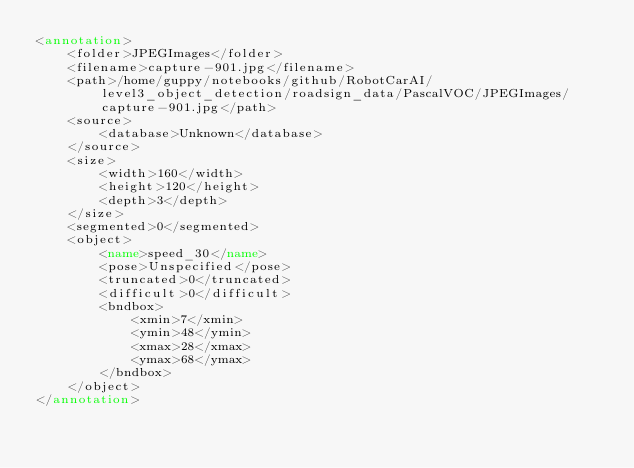Convert code to text. <code><loc_0><loc_0><loc_500><loc_500><_XML_><annotation>
	<folder>JPEGImages</folder>
	<filename>capture-901.jpg</filename>
	<path>/home/guppy/notebooks/github/RobotCarAI/level3_object_detection/roadsign_data/PascalVOC/JPEGImages/capture-901.jpg</path>
	<source>
		<database>Unknown</database>
	</source>
	<size>
		<width>160</width>
		<height>120</height>
		<depth>3</depth>
	</size>
	<segmented>0</segmented>
	<object>
		<name>speed_30</name>
		<pose>Unspecified</pose>
		<truncated>0</truncated>
		<difficult>0</difficult>
		<bndbox>
			<xmin>7</xmin>
			<ymin>48</ymin>
			<xmax>28</xmax>
			<ymax>68</ymax>
		</bndbox>
	</object>
</annotation>
</code> 